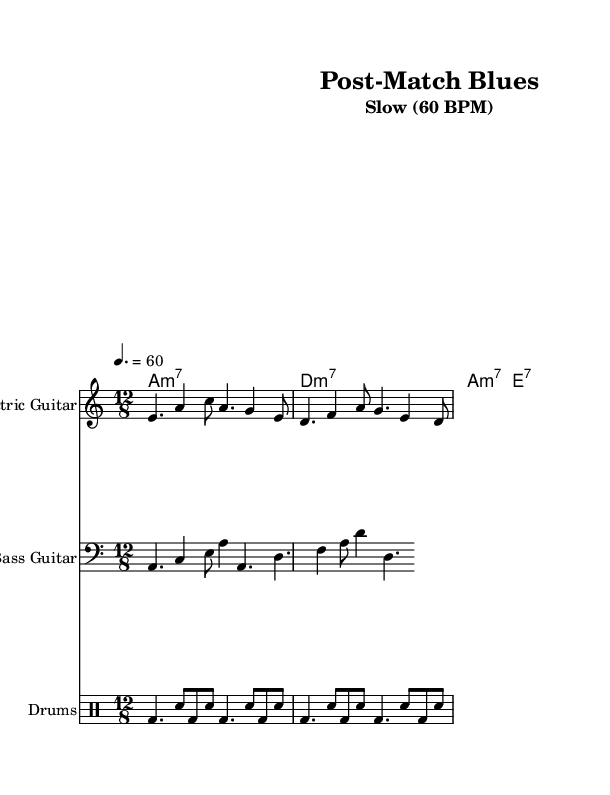What is the key signature of this music? The key signature indicates that the piece is in A minor, which has no sharps or flats. This can be confirmed by looking at the \key instruction in the global settings.
Answer: A minor What is the time signature of this piece? The time signature shown at the beginning of the score indicates that the music is written in 12/8. This is evident from the \time instruction given in the global settings.
Answer: 12/8 What tempo is indicated for this music? The tempo marking in the score indicates a tempo of 60 beats per minute, as specified by the tempo instruction in the global settings.
Answer: 60 BPM How many measures are in the electric guitar part? The electric guitar part consists of two measures, each containing a sequence of notes indicated in the notation. This can be determined by counting the bar lines in the guitar staff.
Answer: 2 measures What is the genre of this music piece? The music is categorized as Electric Blues, which can be inferred from the setting, instrumentation, and musical elements typical of the genre.
Answer: Electric Blues Which instrument has the clef indicating bass? The bass guitar staff uses the bass clef, which can be identified by looking at the clef symbol at the beginning of the bass guitar staff in the score.
Answer: Bass Guitar What type of chords are played in the organ part? The organ part contains minor 7 and dominant 7 chords, as denoted by the chord symbols "m7" and "7" shown clearly in the organ chords section.
Answer: Minor 7 and Dominant 7 